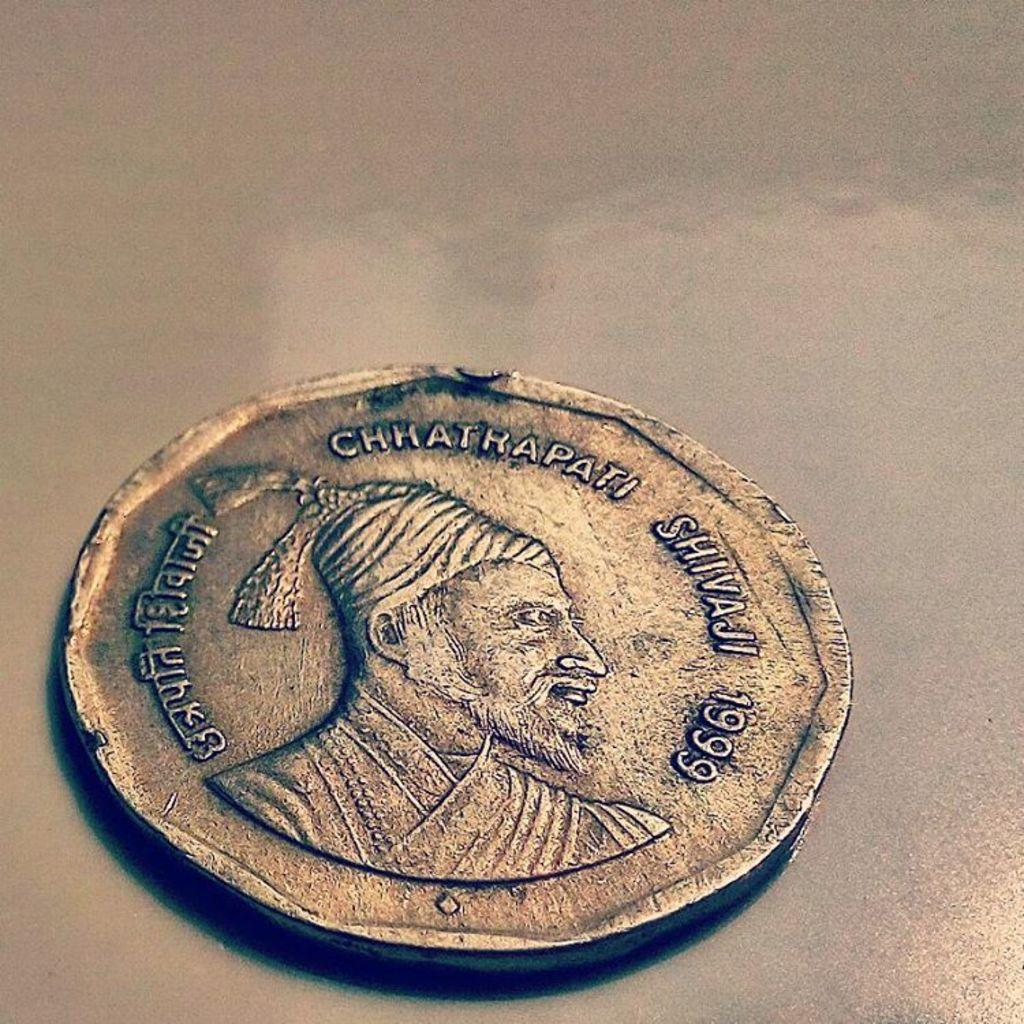<image>
Render a clear and concise summary of the photo. A small gold coin from a foreign country from the year 1999. 